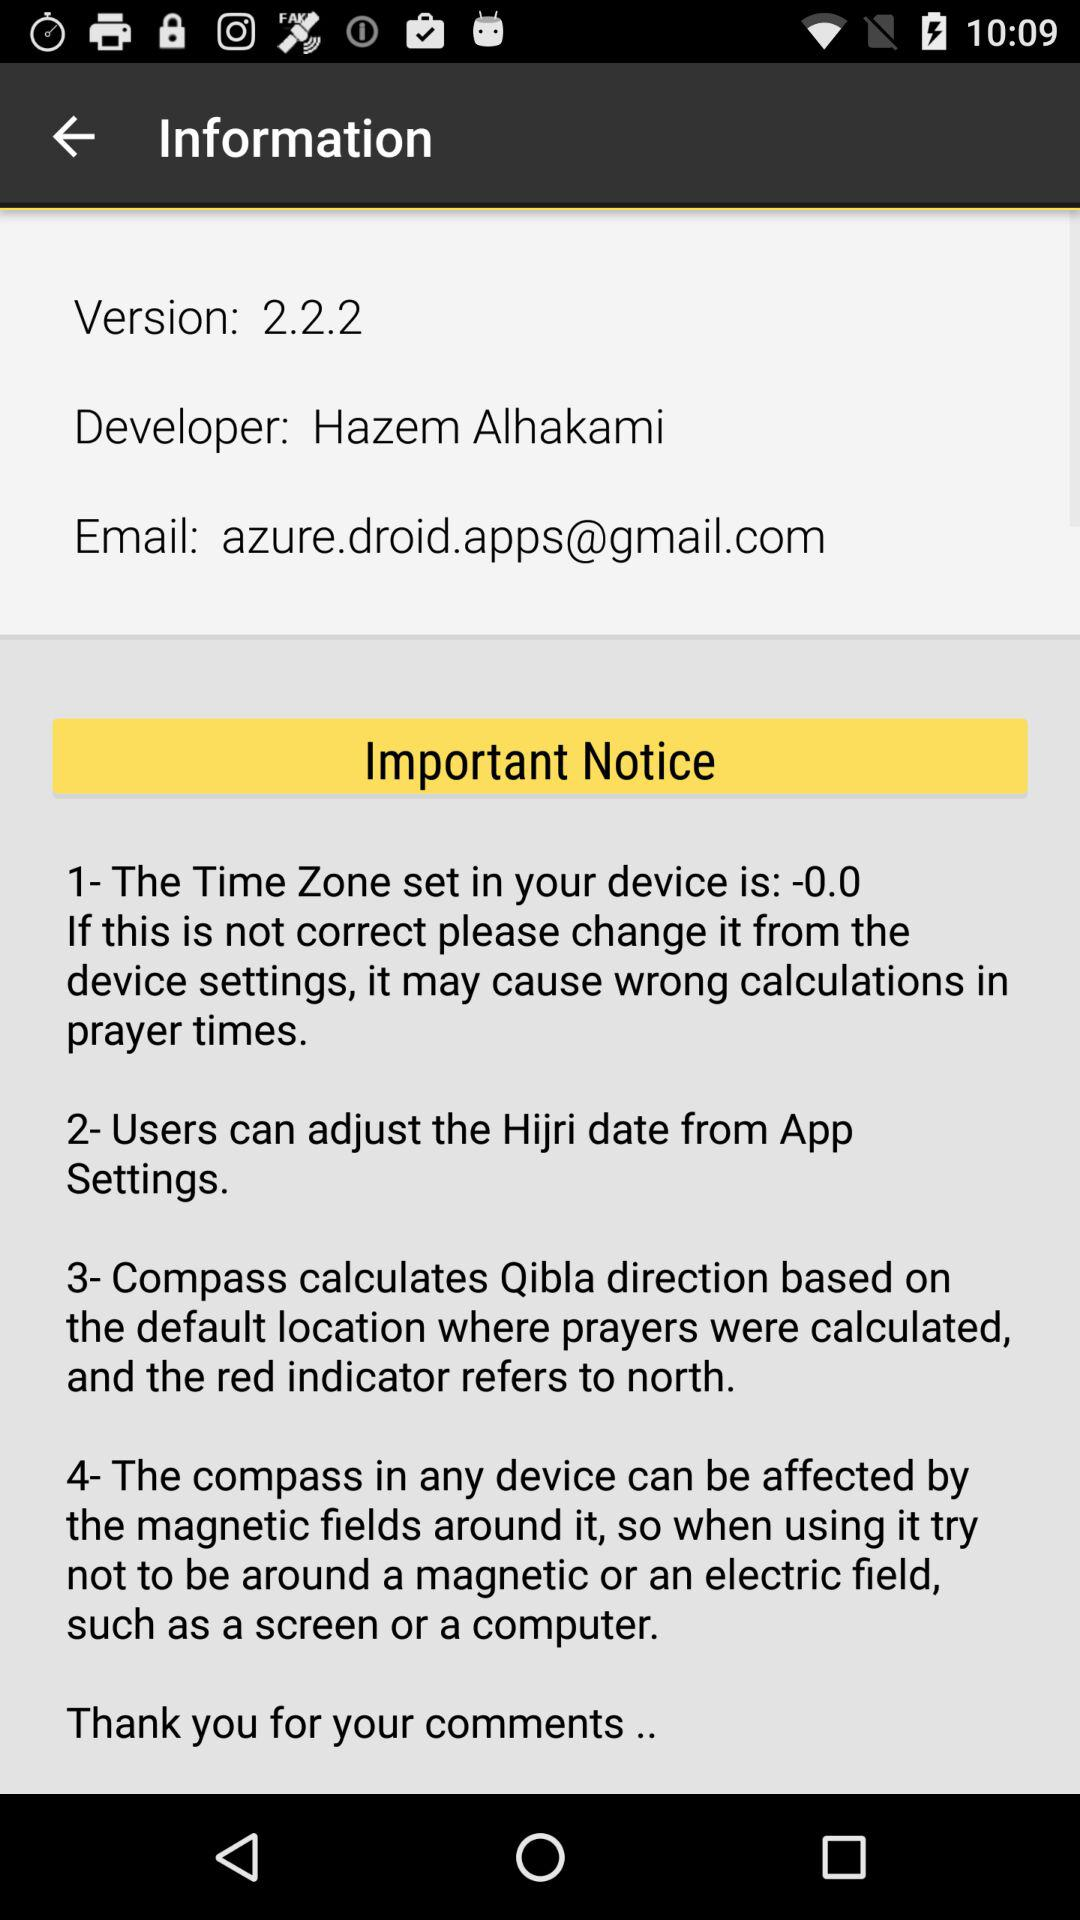What is the email ID? The email ID is azure.droid.apps@gmail.com. 